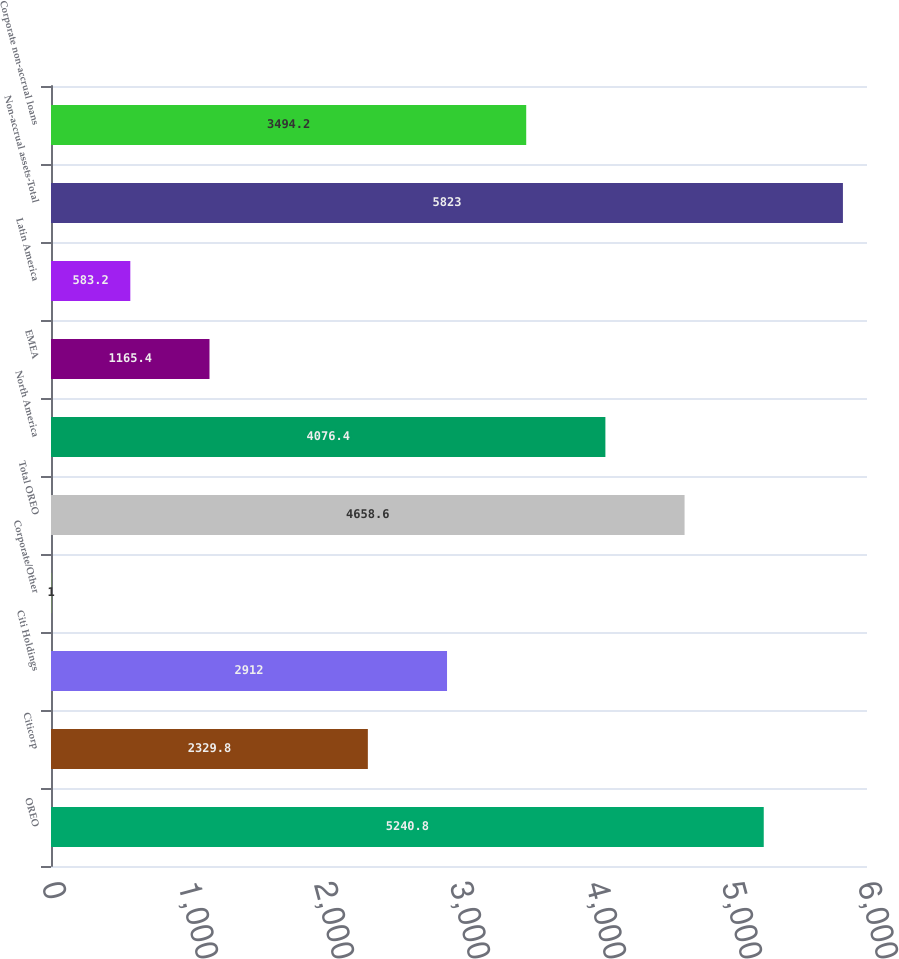<chart> <loc_0><loc_0><loc_500><loc_500><bar_chart><fcel>OREO<fcel>Citicorp<fcel>Citi Holdings<fcel>Corporate/Other<fcel>Total OREO<fcel>North America<fcel>EMEA<fcel>Latin America<fcel>Non-accrual assets-Total<fcel>Corporate non-accrual loans<nl><fcel>5240.8<fcel>2329.8<fcel>2912<fcel>1<fcel>4658.6<fcel>4076.4<fcel>1165.4<fcel>583.2<fcel>5823<fcel>3494.2<nl></chart> 